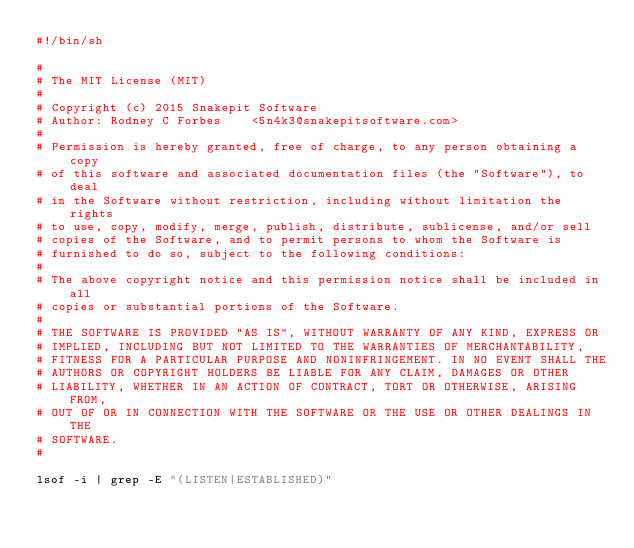<code> <loc_0><loc_0><loc_500><loc_500><_Bash_>#!/bin/sh

#
# The MIT License (MIT)
#
# Copyright (c) 2015 Snakepit Software
# Author: Rodney C Forbes    <5n4k3@snakepitsoftware.com>
#
# Permission is hereby granted, free of charge, to any person obtaining a copy
# of this software and associated documentation files (the "Software"), to deal
# in the Software without restriction, including without limitation the rights
# to use, copy, modify, merge, publish, distribute, sublicense, and/or sell
# copies of the Software, and to permit persons to whom the Software is
# furnished to do so, subject to the following conditions:
#
# The above copyright notice and this permission notice shall be included in all
# copies or substantial portions of the Software.
#
# THE SOFTWARE IS PROVIDED "AS IS", WITHOUT WARRANTY OF ANY KIND, EXPRESS OR
# IMPLIED, INCLUDING BUT NOT LIMITED TO THE WARRANTIES OF MERCHANTABILITY,
# FITNESS FOR A PARTICULAR PURPOSE AND NONINFRINGEMENT. IN NO EVENT SHALL THE
# AUTHORS OR COPYRIGHT HOLDERS BE LIABLE FOR ANY CLAIM, DAMAGES OR OTHER
# LIABILITY, WHETHER IN AN ACTION OF CONTRACT, TORT OR OTHERWISE, ARISING FROM,
# OUT OF OR IN CONNECTION WITH THE SOFTWARE OR THE USE OR OTHER DEALINGS IN THE
# SOFTWARE.
#

lsof -i | grep -E "(LISTEN|ESTABLISHED)"
</code> 